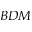Convert formula to latex. <formula><loc_0><loc_0><loc_500><loc_500>B D M</formula> 